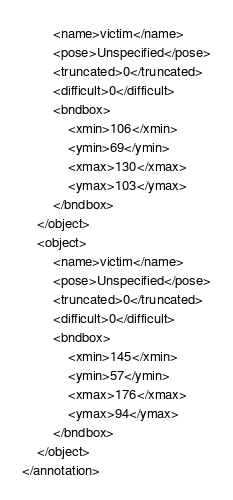Convert code to text. <code><loc_0><loc_0><loc_500><loc_500><_XML_>		<name>victim</name>
		<pose>Unspecified</pose>
		<truncated>0</truncated>
		<difficult>0</difficult>
		<bndbox>
			<xmin>106</xmin>
			<ymin>69</ymin>
			<xmax>130</xmax>
			<ymax>103</ymax>
		</bndbox>
	</object>
	<object>
		<name>victim</name>
		<pose>Unspecified</pose>
		<truncated>0</truncated>
		<difficult>0</difficult>
		<bndbox>
			<xmin>145</xmin>
			<ymin>57</ymin>
			<xmax>176</xmax>
			<ymax>94</ymax>
		</bndbox>
	</object>
</annotation>
</code> 